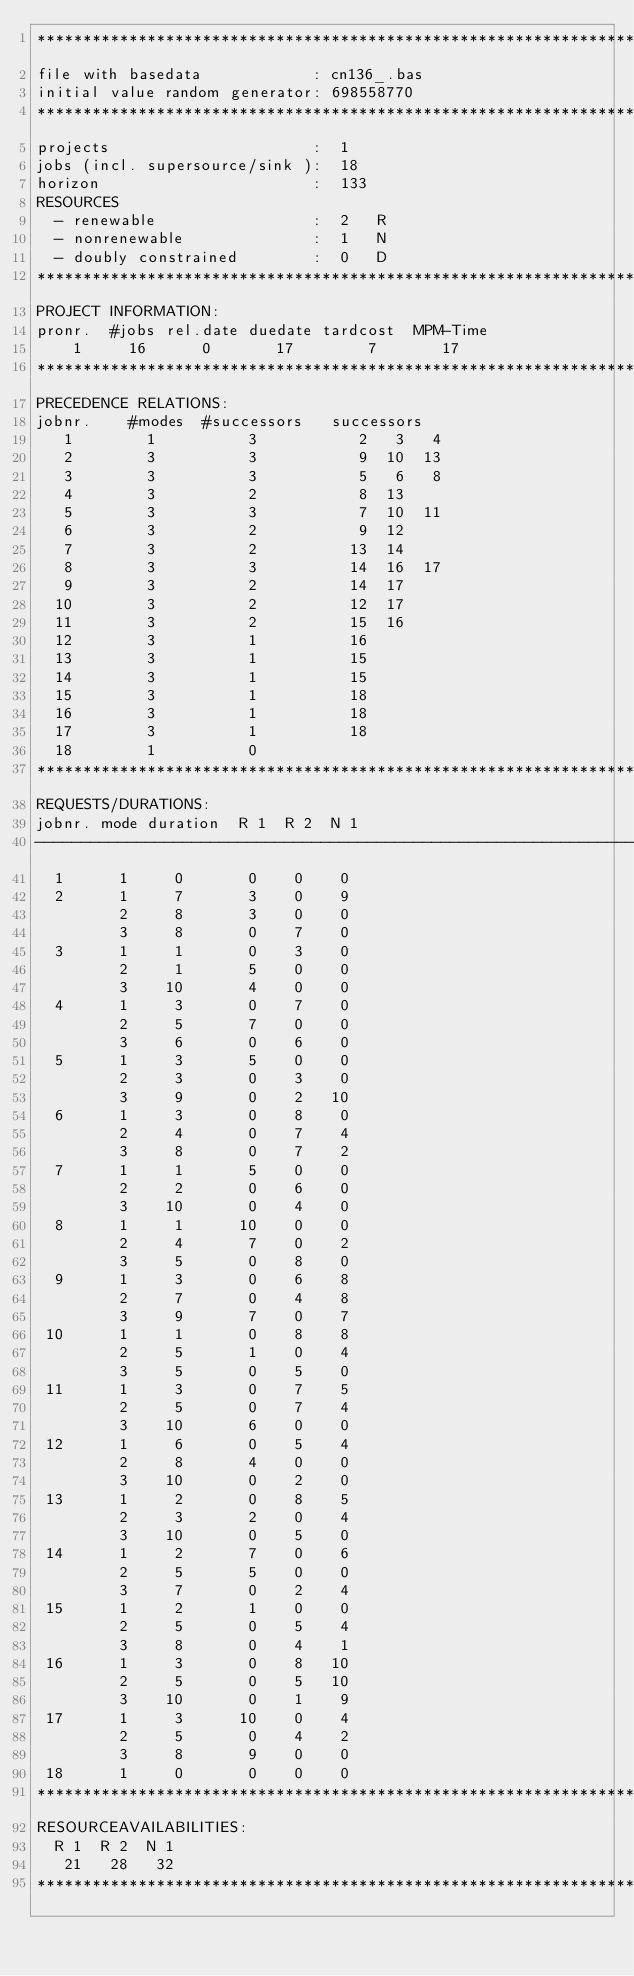Convert code to text. <code><loc_0><loc_0><loc_500><loc_500><_ObjectiveC_>************************************************************************
file with basedata            : cn136_.bas
initial value random generator: 698558770
************************************************************************
projects                      :  1
jobs (incl. supersource/sink ):  18
horizon                       :  133
RESOURCES
  - renewable                 :  2   R
  - nonrenewable              :  1   N
  - doubly constrained        :  0   D
************************************************************************
PROJECT INFORMATION:
pronr.  #jobs rel.date duedate tardcost  MPM-Time
    1     16      0       17        7       17
************************************************************************
PRECEDENCE RELATIONS:
jobnr.    #modes  #successors   successors
   1        1          3           2   3   4
   2        3          3           9  10  13
   3        3          3           5   6   8
   4        3          2           8  13
   5        3          3           7  10  11
   6        3          2           9  12
   7        3          2          13  14
   8        3          3          14  16  17
   9        3          2          14  17
  10        3          2          12  17
  11        3          2          15  16
  12        3          1          16
  13        3          1          15
  14        3          1          15
  15        3          1          18
  16        3          1          18
  17        3          1          18
  18        1          0        
************************************************************************
REQUESTS/DURATIONS:
jobnr. mode duration  R 1  R 2  N 1
------------------------------------------------------------------------
  1      1     0       0    0    0
  2      1     7       3    0    9
         2     8       3    0    0
         3     8       0    7    0
  3      1     1       0    3    0
         2     1       5    0    0
         3    10       4    0    0
  4      1     3       0    7    0
         2     5       7    0    0
         3     6       0    6    0
  5      1     3       5    0    0
         2     3       0    3    0
         3     9       0    2   10
  6      1     3       0    8    0
         2     4       0    7    4
         3     8       0    7    2
  7      1     1       5    0    0
         2     2       0    6    0
         3    10       0    4    0
  8      1     1      10    0    0
         2     4       7    0    2
         3     5       0    8    0
  9      1     3       0    6    8
         2     7       0    4    8
         3     9       7    0    7
 10      1     1       0    8    8
         2     5       1    0    4
         3     5       0    5    0
 11      1     3       0    7    5
         2     5       0    7    4
         3    10       6    0    0
 12      1     6       0    5    4
         2     8       4    0    0
         3    10       0    2    0
 13      1     2       0    8    5
         2     3       2    0    4
         3    10       0    5    0
 14      1     2       7    0    6
         2     5       5    0    0
         3     7       0    2    4
 15      1     2       1    0    0
         2     5       0    5    4
         3     8       0    4    1
 16      1     3       0    8   10
         2     5       0    5   10
         3    10       0    1    9
 17      1     3      10    0    4
         2     5       0    4    2
         3     8       9    0    0
 18      1     0       0    0    0
************************************************************************
RESOURCEAVAILABILITIES:
  R 1  R 2  N 1
   21   28   32
************************************************************************
</code> 